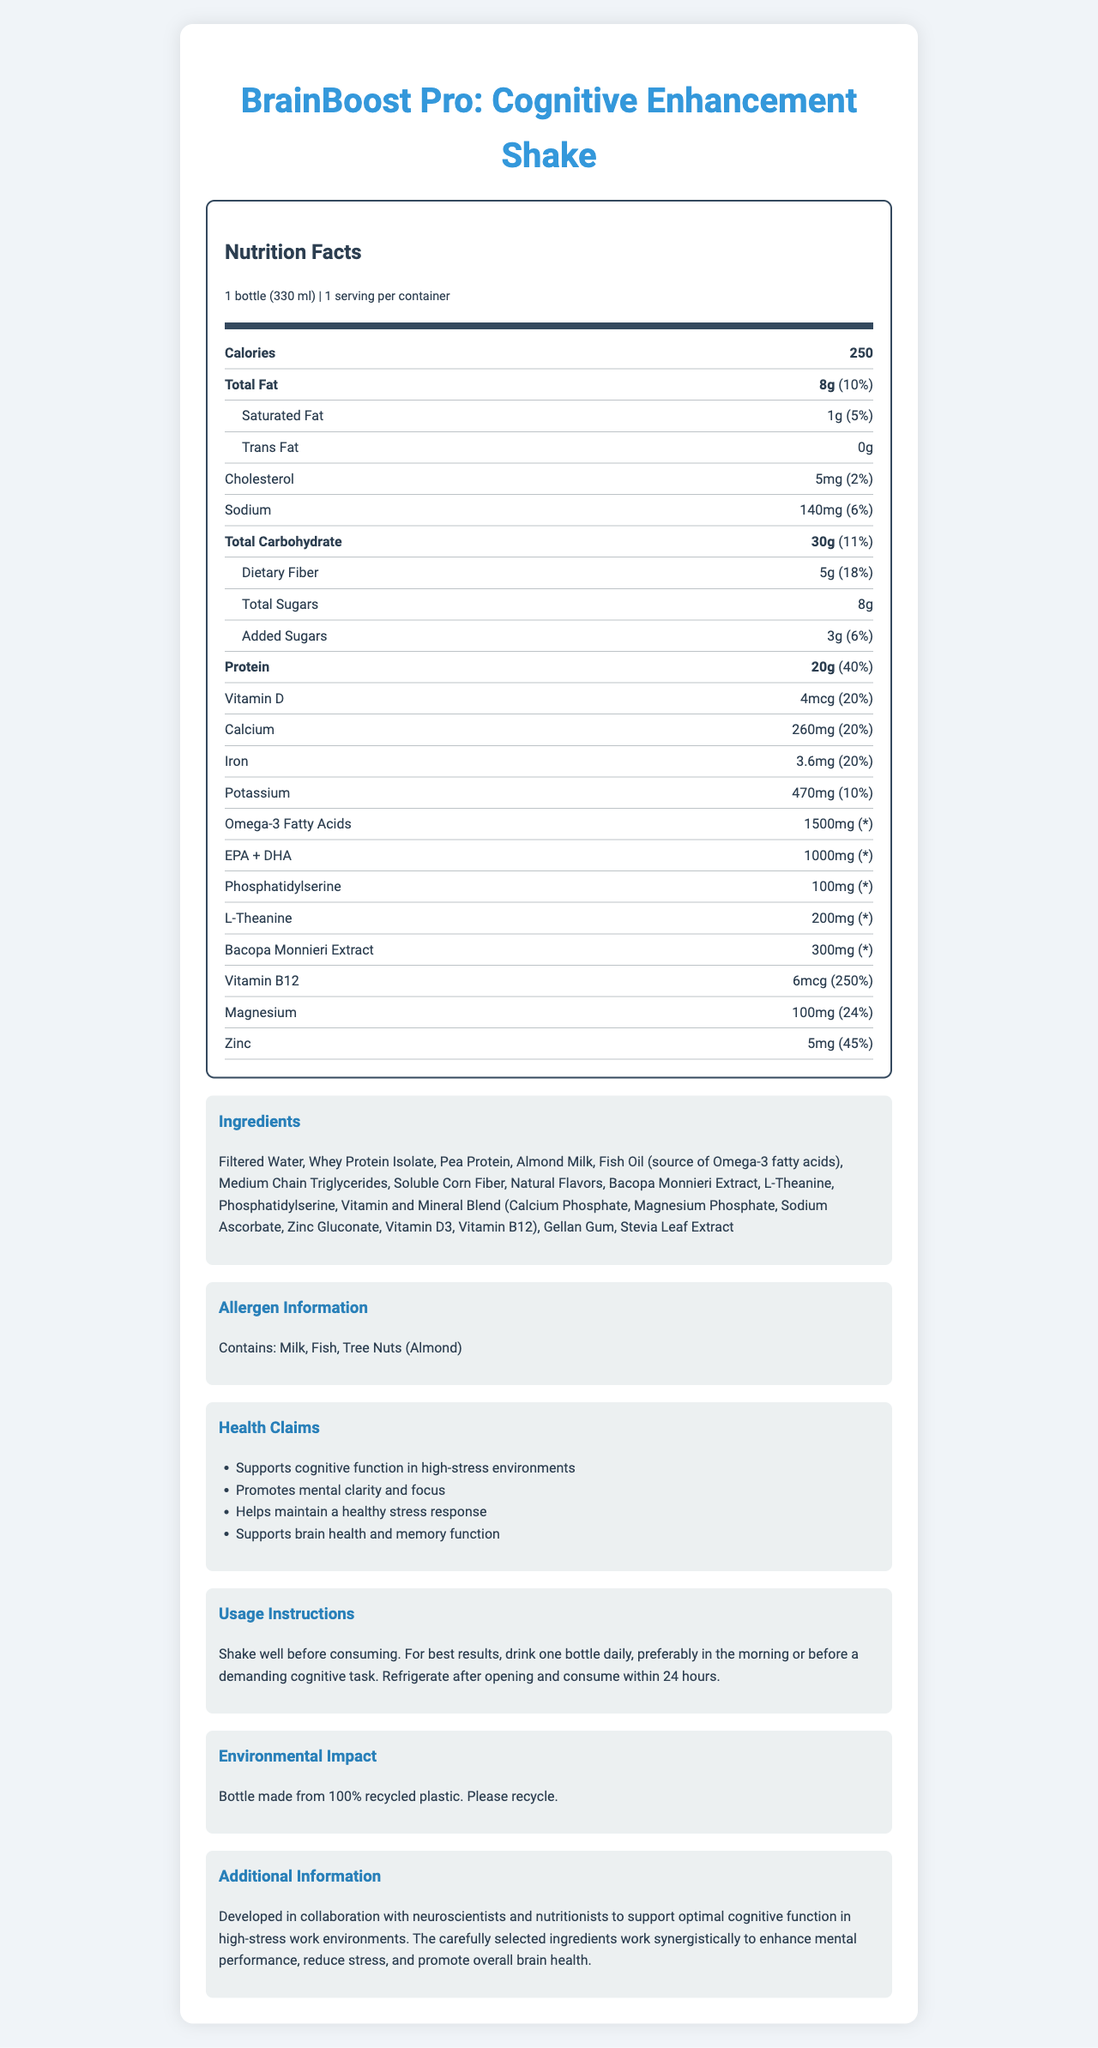what is the serving size? The serving size is stated as "1 bottle (330 ml)" on the nutrition facts label.
Answer: 1 bottle (330 ml) how much protein is in one bottle of the shake? The nutrition facts label indicates that each bottle contains 20g of protein.
Answer: 20g what is the daily value percentage of vitamin B12? The label shows that the daily value percentage for vitamin B12 is 250%.
Answer: 250% what ingredients does this product contain? The ingredients are listed under the "Ingredients" section.
Answer: Filtered Water, Whey Protein Isolate, Pea Protein, Almond Milk, Fish Oil (source of Omega-3 fatty acids), Medium Chain Triglycerides, Soluble Corn Fiber, Natural Flavors, Bacopa Monnieri Extract, L-Theanine, Phosphatidylserine, Vitamin and Mineral Blend (Calcium Phosphate, Magnesium Phosphate, Sodium Ascorbate, Zinc Gluconate, Vitamin D3, Vitamin B12), Gellan Gum, Stevia Leaf Extract what is the main health benefit of this product? The first health claim listed is "Supports cognitive function in high-stress environments".
Answer: Supports cognitive function in high-stress environments how many grams of total carbohydrates are in the product? A. 15g B. 30g C. 45g D. 60g The nutrition facts label shows that the total carbohydrate content is 30g.
Answer: B. 30g what is the correct daily value percentage for magnesium? A. 24% B. 10% C. 5% D. 45% The daily value for magnesium is listed as 24%.
Answer: A. 24% Does this product contain tree nuts? The allergen information states that the product contains tree nuts (Almond).
Answer: Yes is this product suitable for individuals with milk allergies? The allergen information indicates that the product contains milk.
Answer: No Summarize the main idea of the product. The product is a meal replacement shake aimed at improving cognitive function in high-stress work environments. It includes a detailed nutrition facts label, ingredient list, allergen information, health claims, usage instructions, and mentions its environmental impact.
Answer: BrainBoost Pro: Cognitive Enhancement Shake is designed to support cognitive function, reduce stress, and promote brain health, containing various beneficial ingredients such as omega-3 fatty acids, Bacopa Monnieri Extract, and L-Theanine. What is the main source of omega-3 fatty acids in the product? The ingredient list specifies that fish oil is the source of omega-3 fatty acids.
Answer: Fish Oil What is the total amount of calories in one serving of the shake? The nutrition facts label indicates that one serving contains 250 calories.
Answer: 250 How much iron is in the product? The label reveals that the product contains 3.6mg of iron.
Answer: 3.6mg What should be done with the bottle after consuming the shake? The environmental impact section mentions that the bottle is made from 100% recycled plastic and should be recycled.
Answer: Please recycle When is it recommended to consume the shake for best results? The usage instructions suggest drinking one bottle daily, preferably in the morning or before a demanding cognitive task.
Answer: Preferably in the morning or before a demanding cognitive task Does the document mention the origin of the fish oil? The document lists fish oil as an ingredient but does not state the origin of the fish oil.
Answer: Cannot be determined 